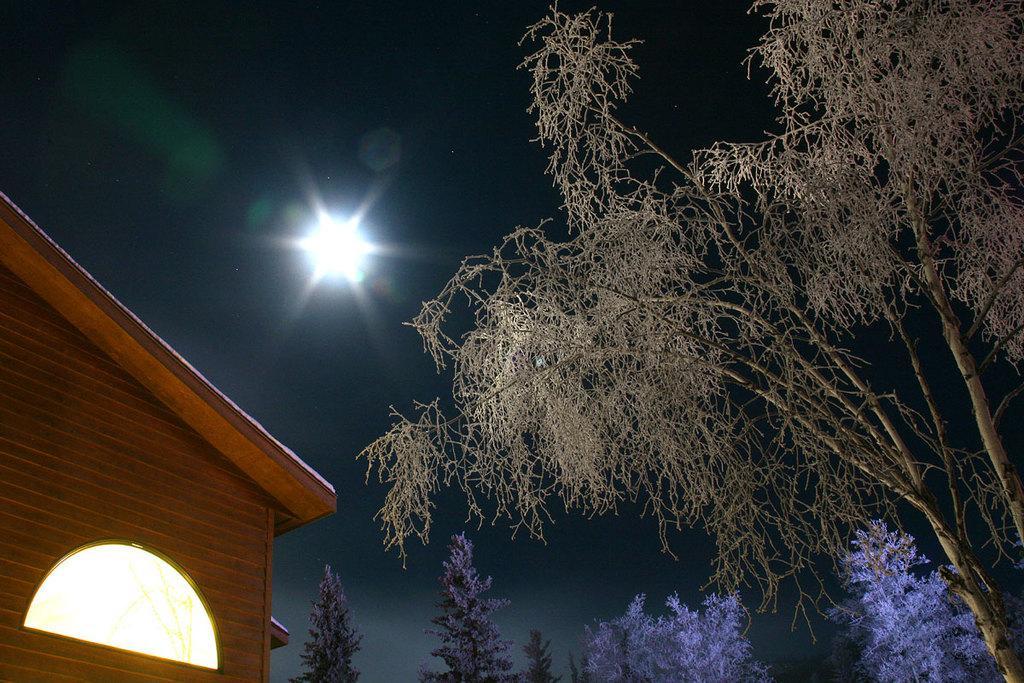Can you describe this image briefly? In this image we can see a group of trees. On the left side, we can see a house. At the top we can see a light in the sky. 